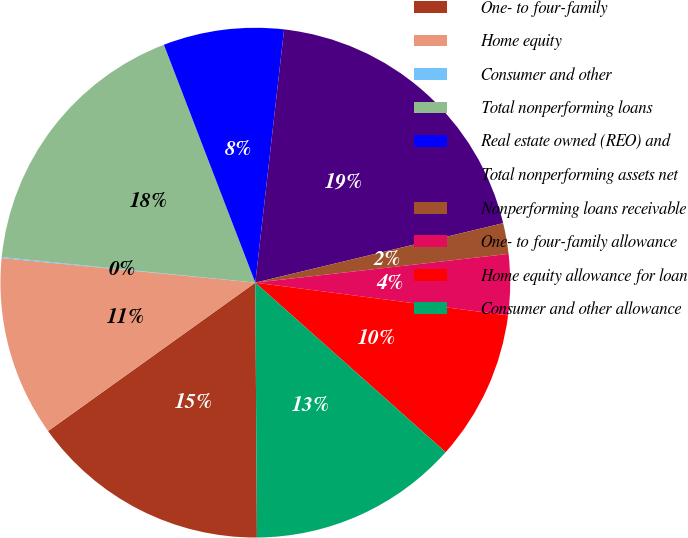Convert chart to OTSL. <chart><loc_0><loc_0><loc_500><loc_500><pie_chart><fcel>One- to four-family<fcel>Home equity<fcel>Consumer and other<fcel>Total nonperforming loans<fcel>Real estate owned (REO) and<fcel>Total nonperforming assets net<fcel>Nonperforming loans receivable<fcel>One- to four-family allowance<fcel>Home equity allowance for loan<fcel>Consumer and other allowance<nl><fcel>15.21%<fcel>11.43%<fcel>0.06%<fcel>17.56%<fcel>7.64%<fcel>19.45%<fcel>1.95%<fcel>3.85%<fcel>9.53%<fcel>13.32%<nl></chart> 